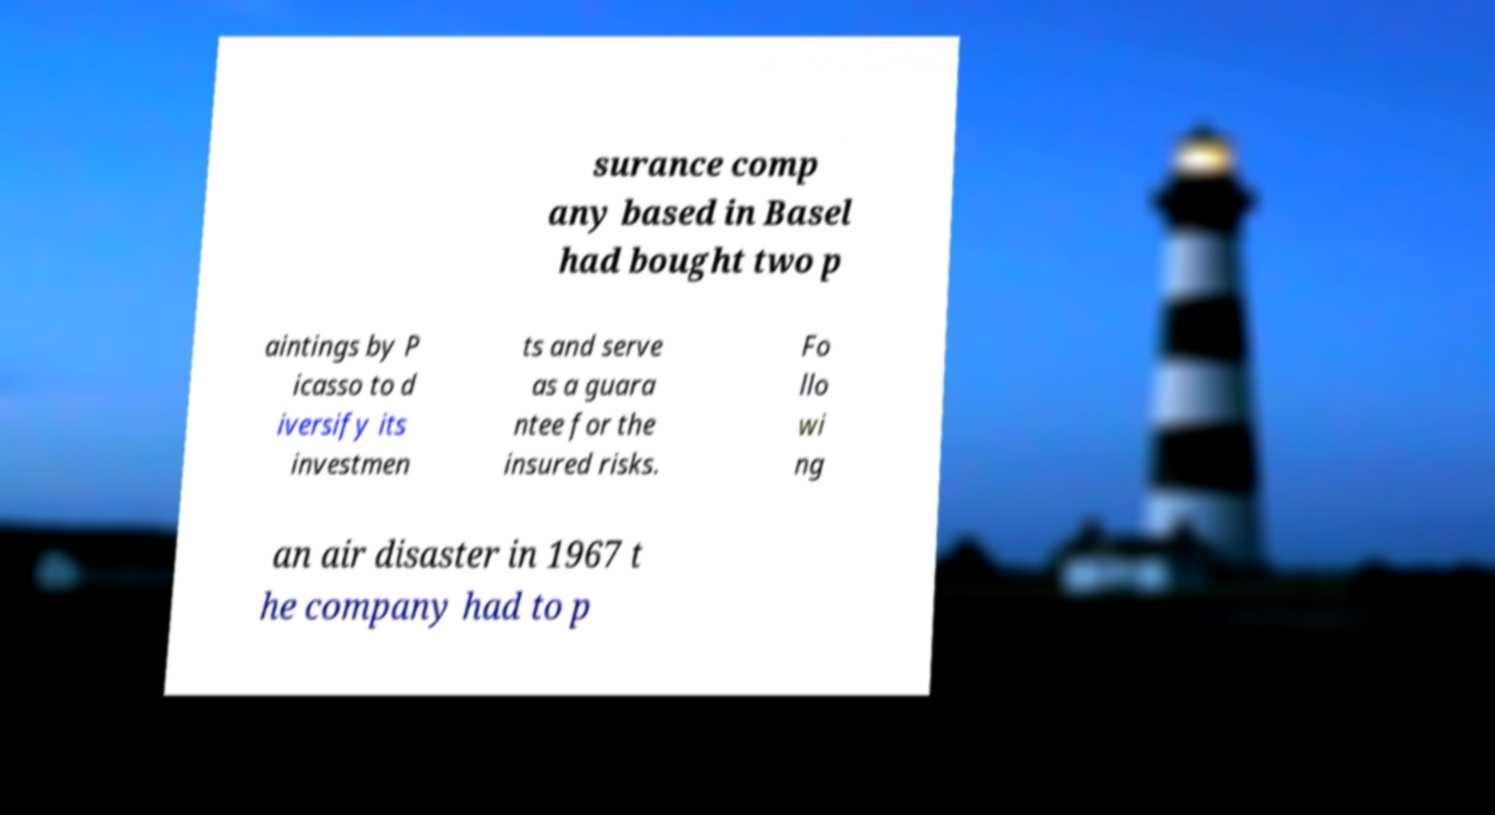Please identify and transcribe the text found in this image. surance comp any based in Basel had bought two p aintings by P icasso to d iversify its investmen ts and serve as a guara ntee for the insured risks. Fo llo wi ng an air disaster in 1967 t he company had to p 